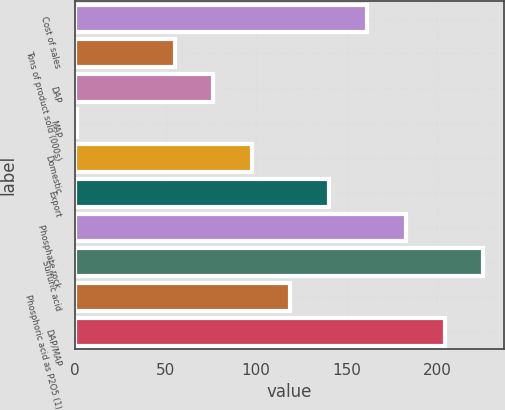<chart> <loc_0><loc_0><loc_500><loc_500><bar_chart><fcel>Cost of sales<fcel>Tons of product sold (000s)<fcel>DAP<fcel>MAP<fcel>Domestic<fcel>Export<fcel>Phosphate rock<fcel>Sulfuric acid<fcel>Phosphoric acid as P2O5 (1)<fcel>DAP/MAP<nl><fcel>161.5<fcel>55<fcel>76.3<fcel>1<fcel>97.6<fcel>140.2<fcel>182.8<fcel>225.4<fcel>118.9<fcel>204.1<nl></chart> 